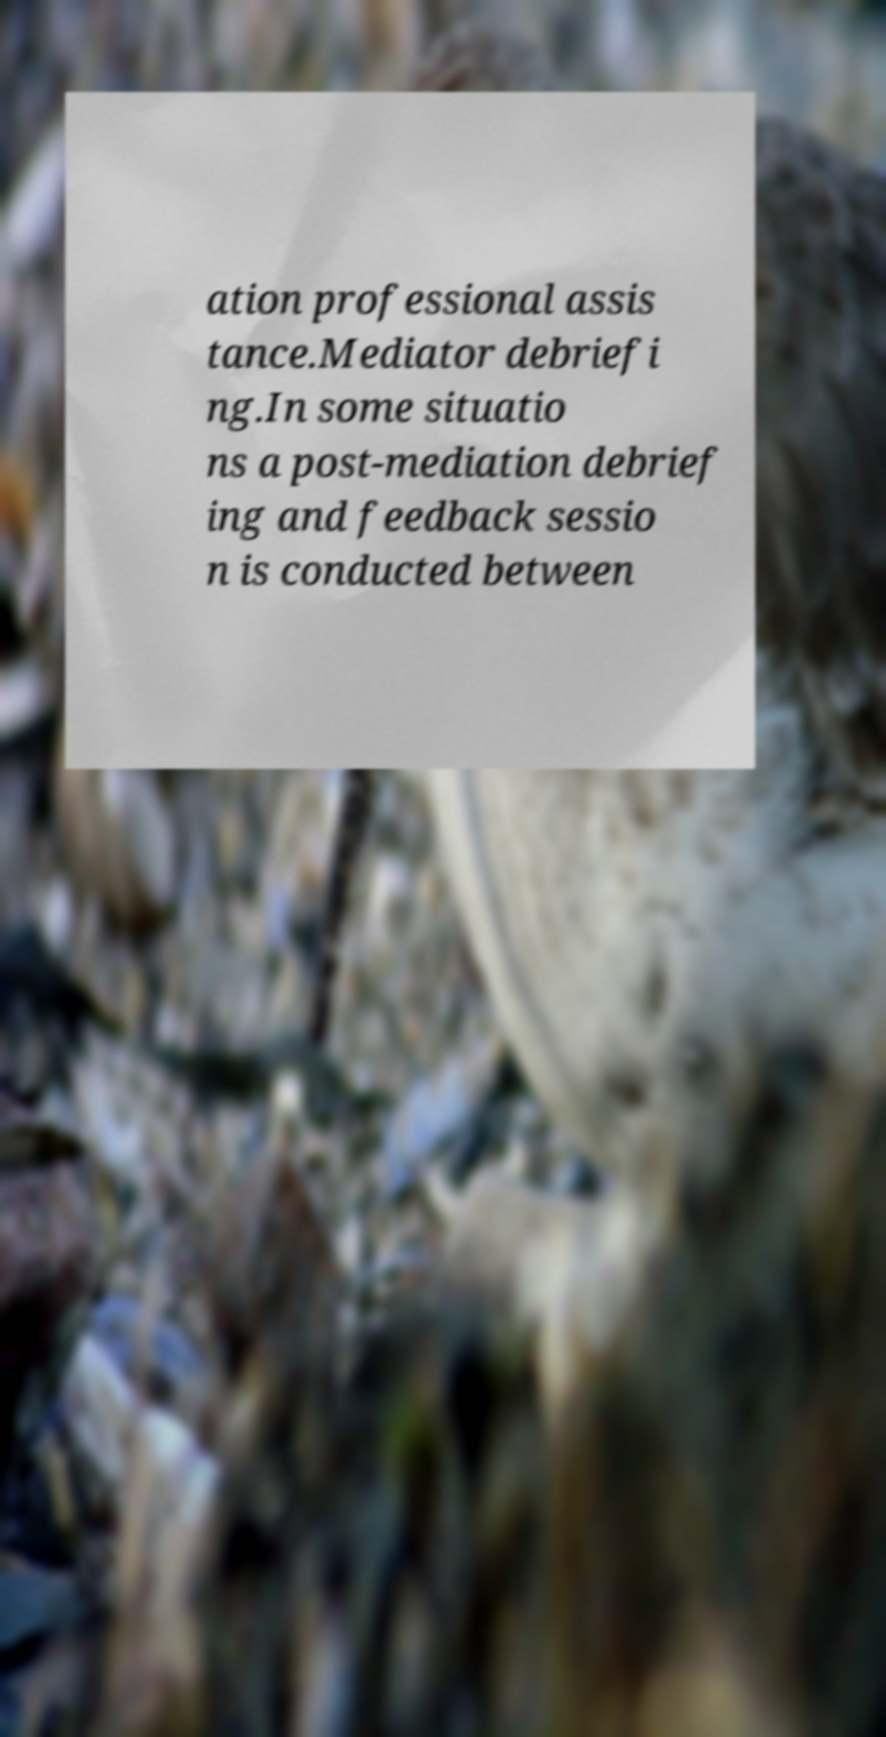Could you assist in decoding the text presented in this image and type it out clearly? ation professional assis tance.Mediator debriefi ng.In some situatio ns a post-mediation debrief ing and feedback sessio n is conducted between 